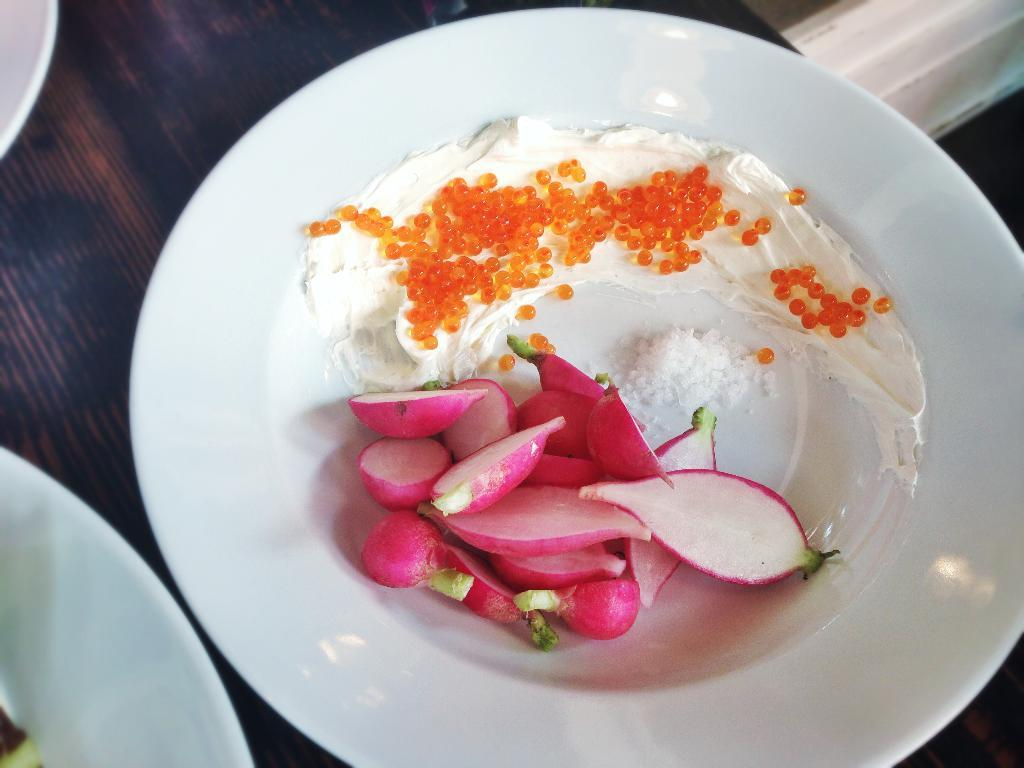What is located in the center of the image? There is a plate in the center of the image. What is on the plate? The plate contains food items. What can be seen in the top left and right sides of the image? Other planets are visible in the top left and right sides of the image. What type of fire can be seen coming from the food on the plate? There is no fire present on the plate or in the image. 